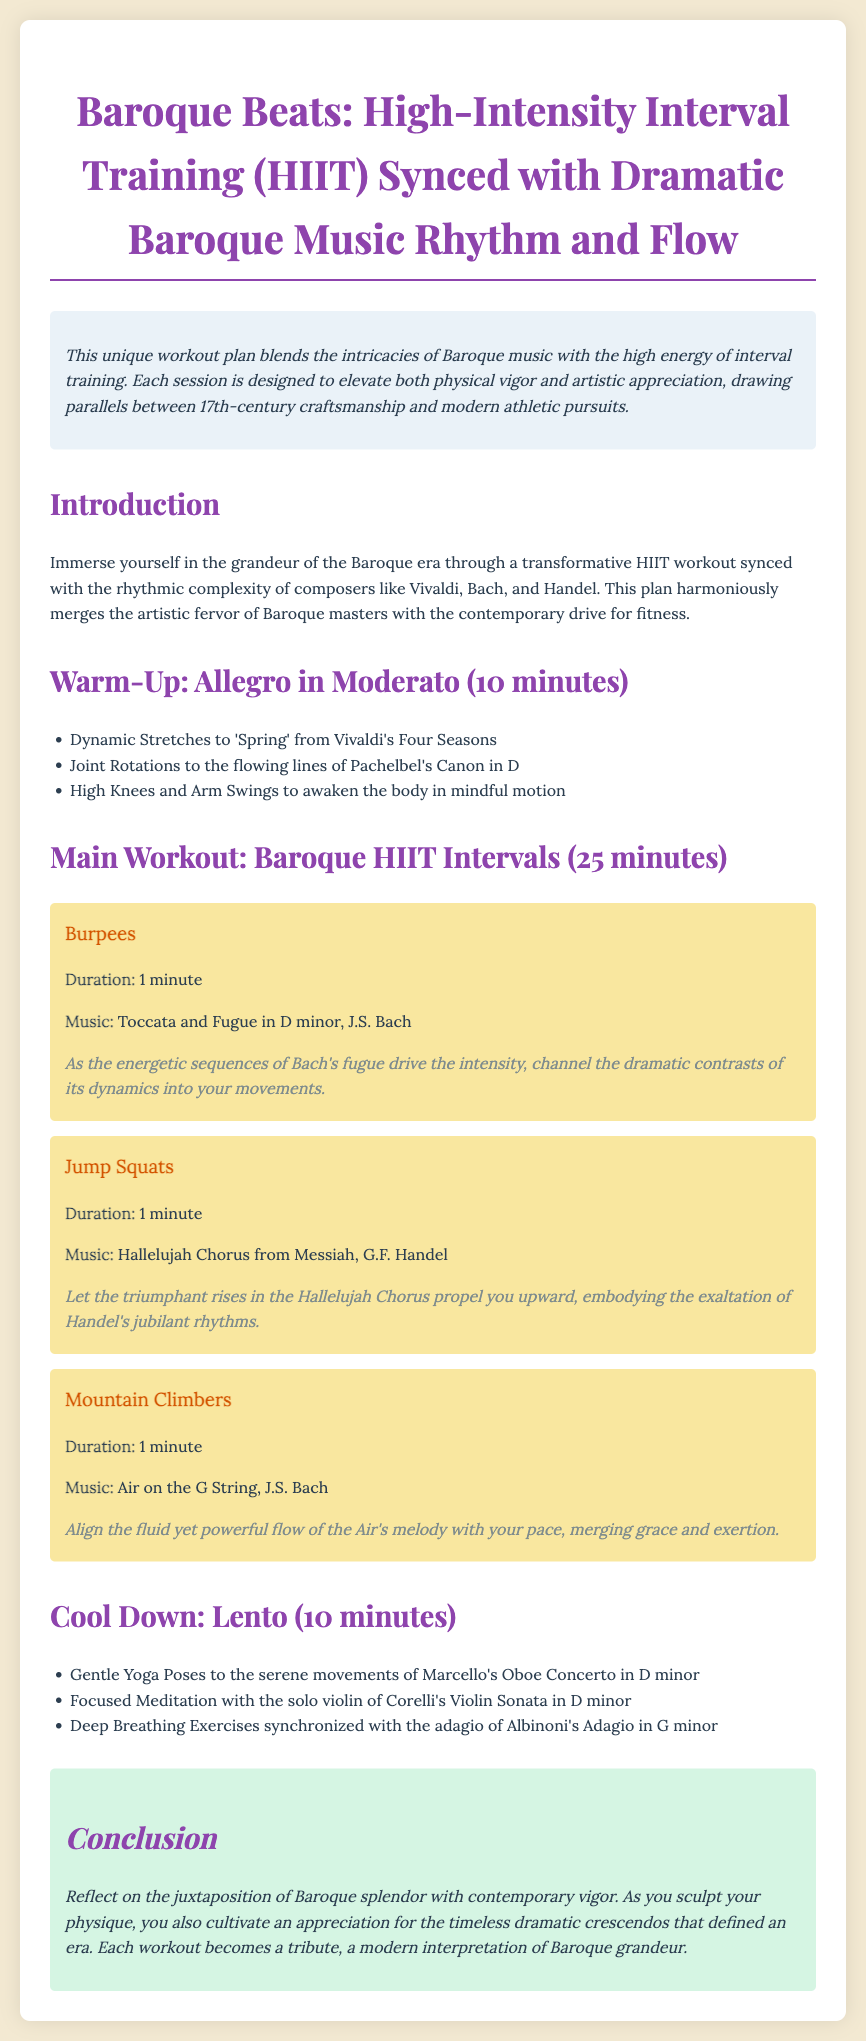What is the title of the workout plan? The title is mentioned at the top of the document, summarizing the content of the workout.
Answer: Baroque Beats: High-Intensity Interval Training (HIIT) Synced with Dramatic Baroque Music Rhythm and Flow Who composed the Toccata and Fugue in D minor? This is specified in the intervals section where the corresponding music is associated with the exercises.
Answer: J.S. Bach How long is the warm-up phase? The duration of the warm-up phase is explicitly stated in the warm-up section.
Answer: 10 minutes What type of exercise follows Jump Squats in the main workout? This asks for the sequence of exercises listed under the main workout section.
Answer: Mountain Climbers What is the purpose of the cool down? This is inferred from the activities listed in the cool-down section, aiming to bring the body back to equilibrium after the workout.
Answer: Gentle Yoga Poses, Focused Meditation, Deep Breathing Exercises Which Baroque piece accompanies Mountain Climbers? The specific piece of music played during the exercise is noted in the main workout intervals.
Answer: Air on the G String What is the final reflection in the conclusion section about? The conclusion invites personal reflection on the workout's artistry and connections with Baroque music.
Answer: Juxtaposition of Baroque splendor with contemporary vigor What is the main theme of the workout plan? The introduction outlines the central theme of merging music and exercise.
Answer: Blends intricacies of Baroque music with high energy of interval training 